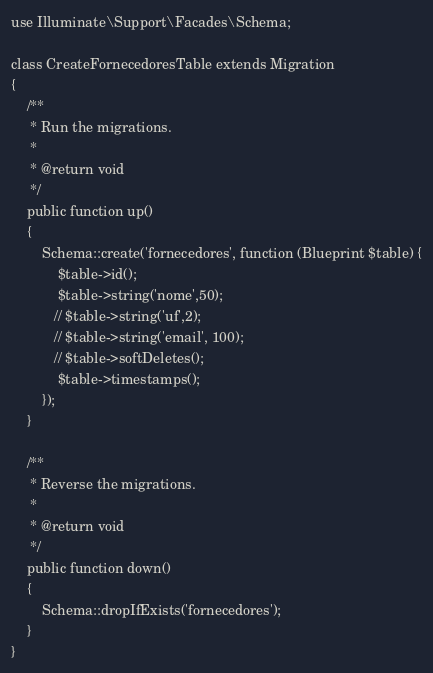Convert code to text. <code><loc_0><loc_0><loc_500><loc_500><_PHP_>use Illuminate\Support\Facades\Schema;

class CreateFornecedoresTable extends Migration
{
    /**
     * Run the migrations.
     *
     * @return void
     */
    public function up()
    {
        Schema::create('fornecedores', function (Blueprint $table) {
            $table->id();
            $table->string('nome',50);
           // $table->string('uf',2);
           // $table->string('email', 100);
           // $table->softDeletes();
            $table->timestamps();
        });
    }

    /**
     * Reverse the migrations.
     *
     * @return void
     */
    public function down()
    {
        Schema::dropIfExists('fornecedores');
    }
}
</code> 